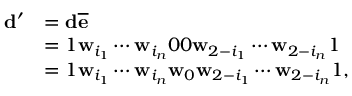Convert formula to latex. <formula><loc_0><loc_0><loc_500><loc_500>\begin{array} { r l } { \mathbf d ^ { \prime } } & { = \mathbf d \overline { \mathbf e } } \\ & { = 1 \mathbf w _ { i _ { 1 } } \cdots \mathbf w _ { i _ { n } } 0 0 \mathbf w _ { 2 - i _ { 1 } } \cdots \mathbf w _ { 2 - i _ { n } } 1 } \\ & { = 1 \mathbf w _ { i _ { 1 } } \cdots \mathbf w _ { i _ { n } } \mathbf w _ { 0 } \mathbf w _ { 2 - i _ { 1 } } \cdots \mathbf w _ { 2 - i _ { n } } 1 , } \end{array}</formula> 